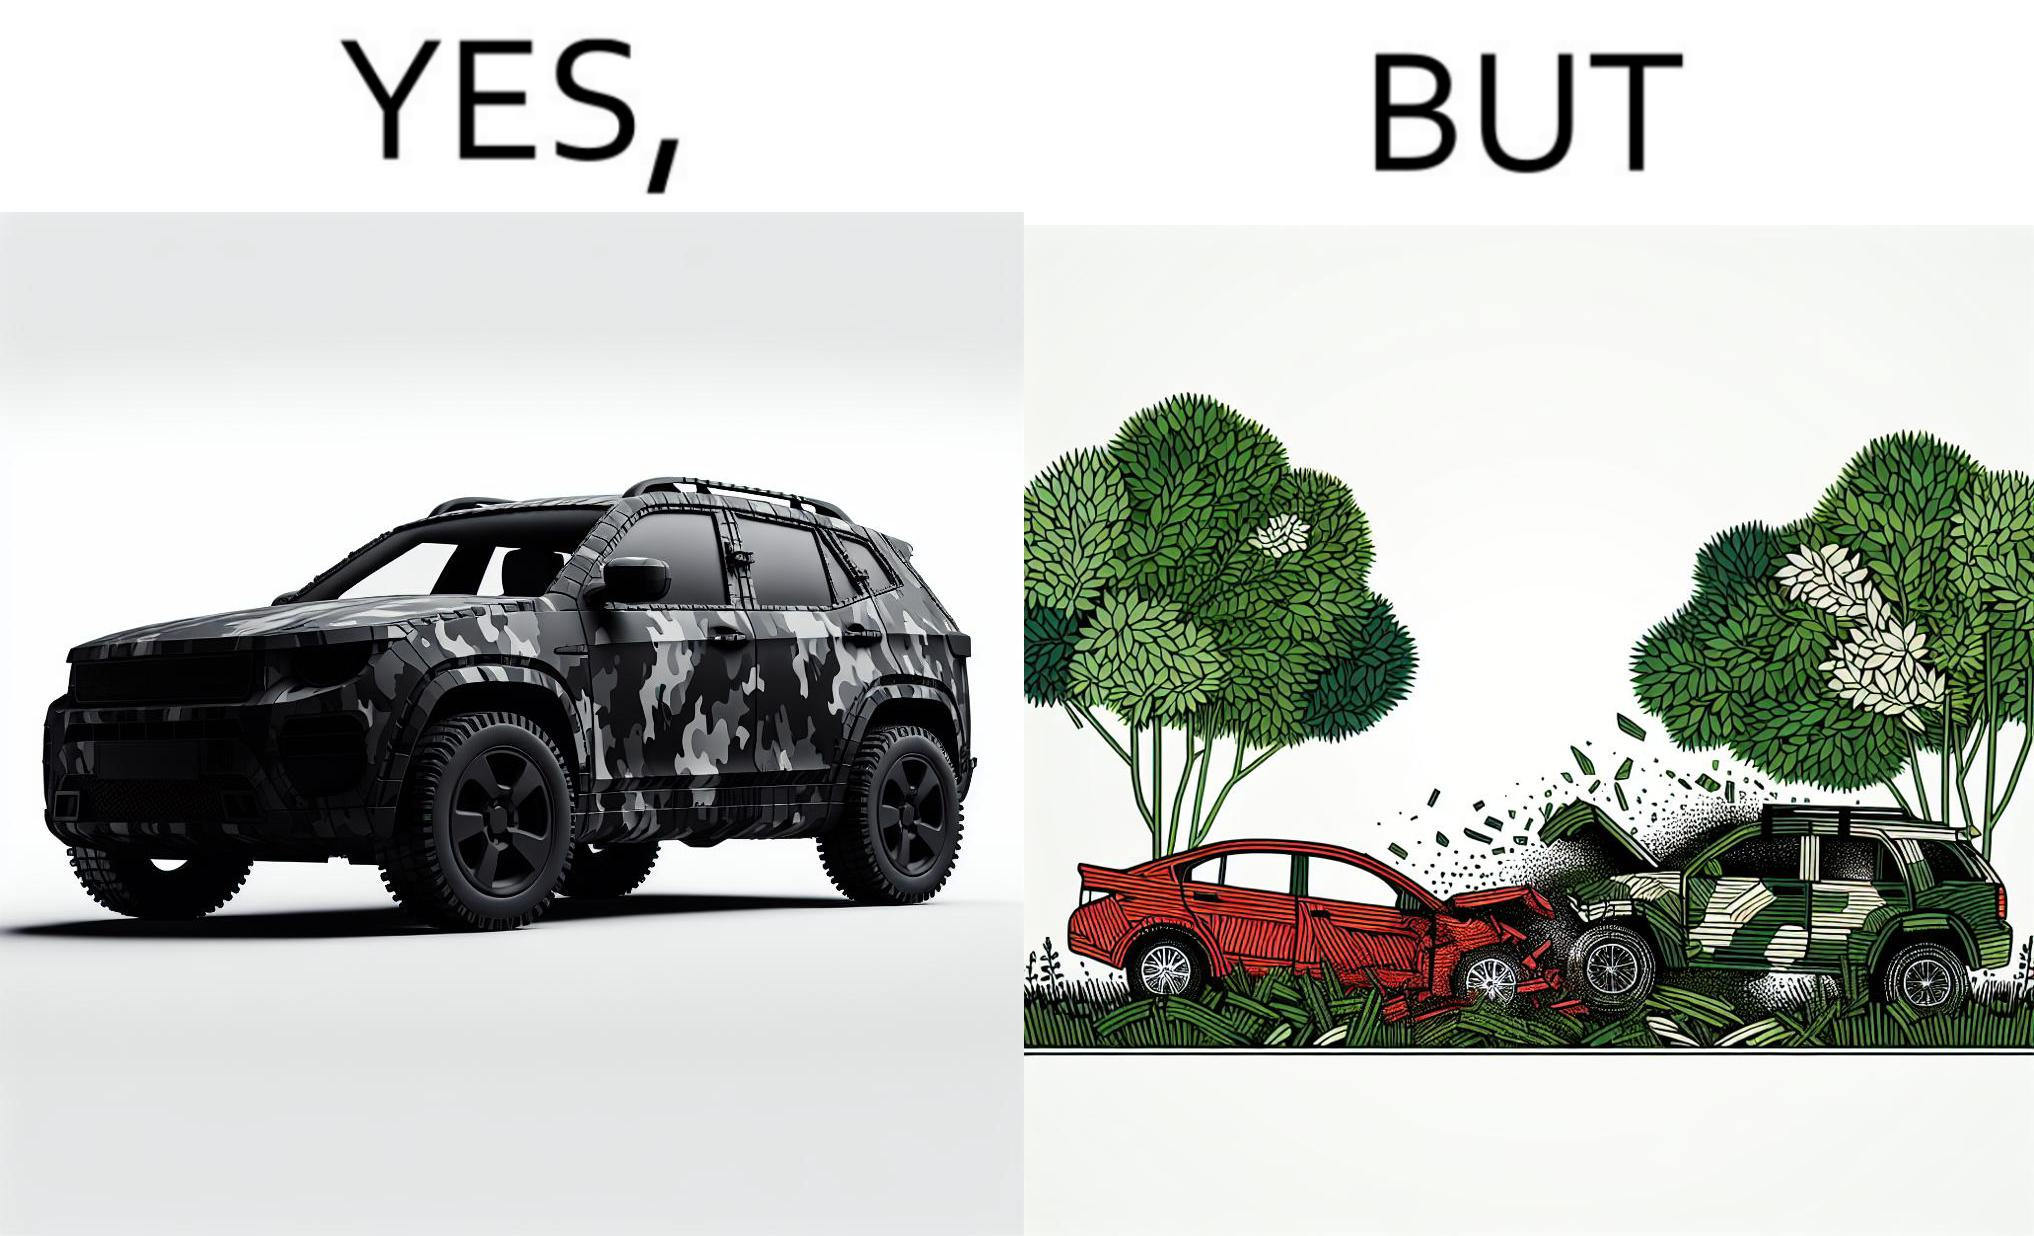Describe the contrast between the left and right parts of this image. In the left part of the image: a car painted in a camouflage color In the right part of the image: a red color car crashing into a camouflage color car due to the background of green plants 